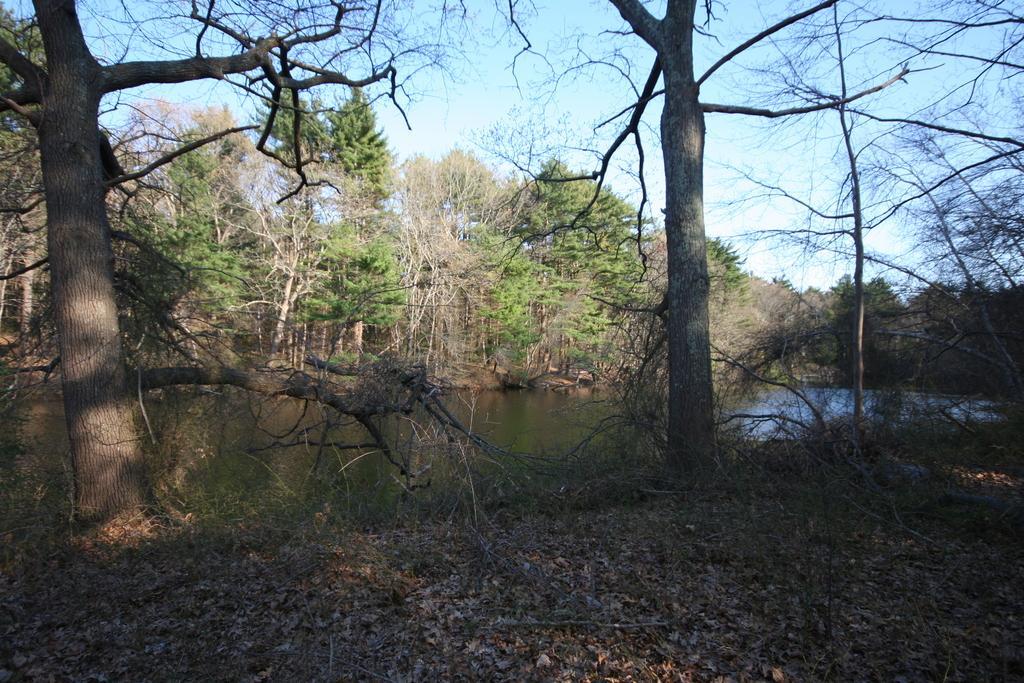Describe this image in one or two sentences. In the picture we can see a path with full of dried leaves and two dried trees and behind it, we can see water and far away from it, we can see, full of trees some are dried and behind it we can see a sky. 